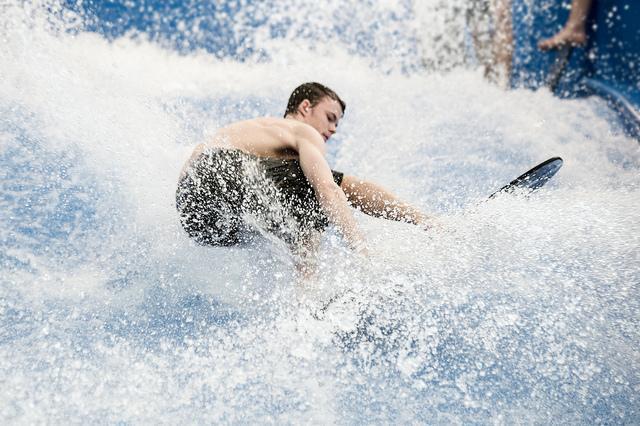How many people can you see?
Give a very brief answer. 2. 